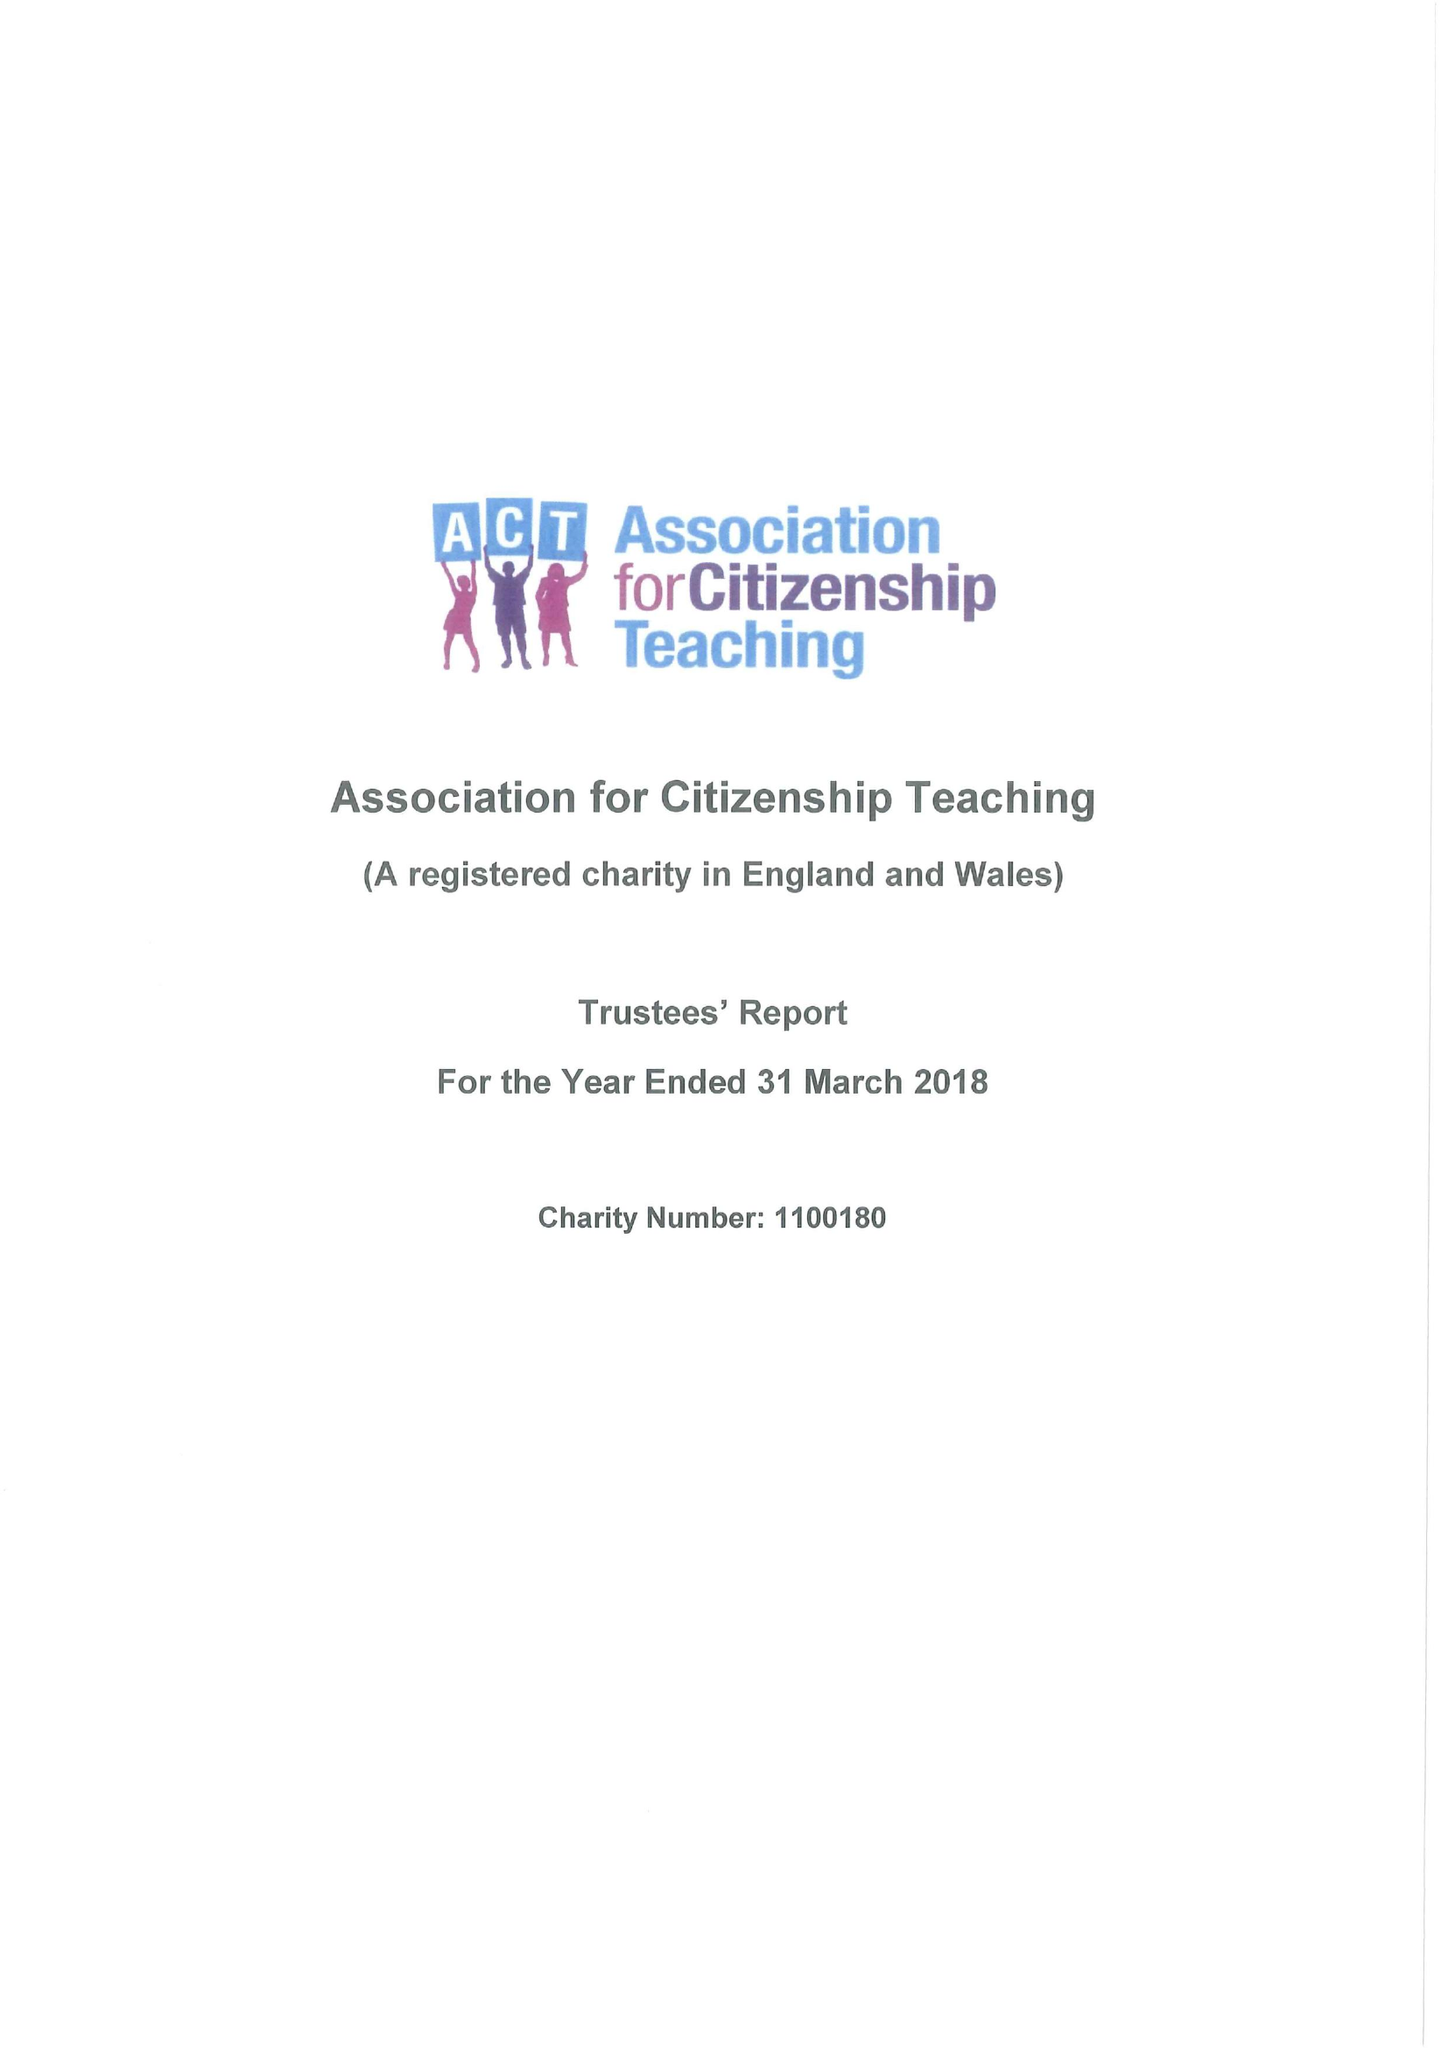What is the value for the charity_number?
Answer the question using a single word or phrase. 1100180 